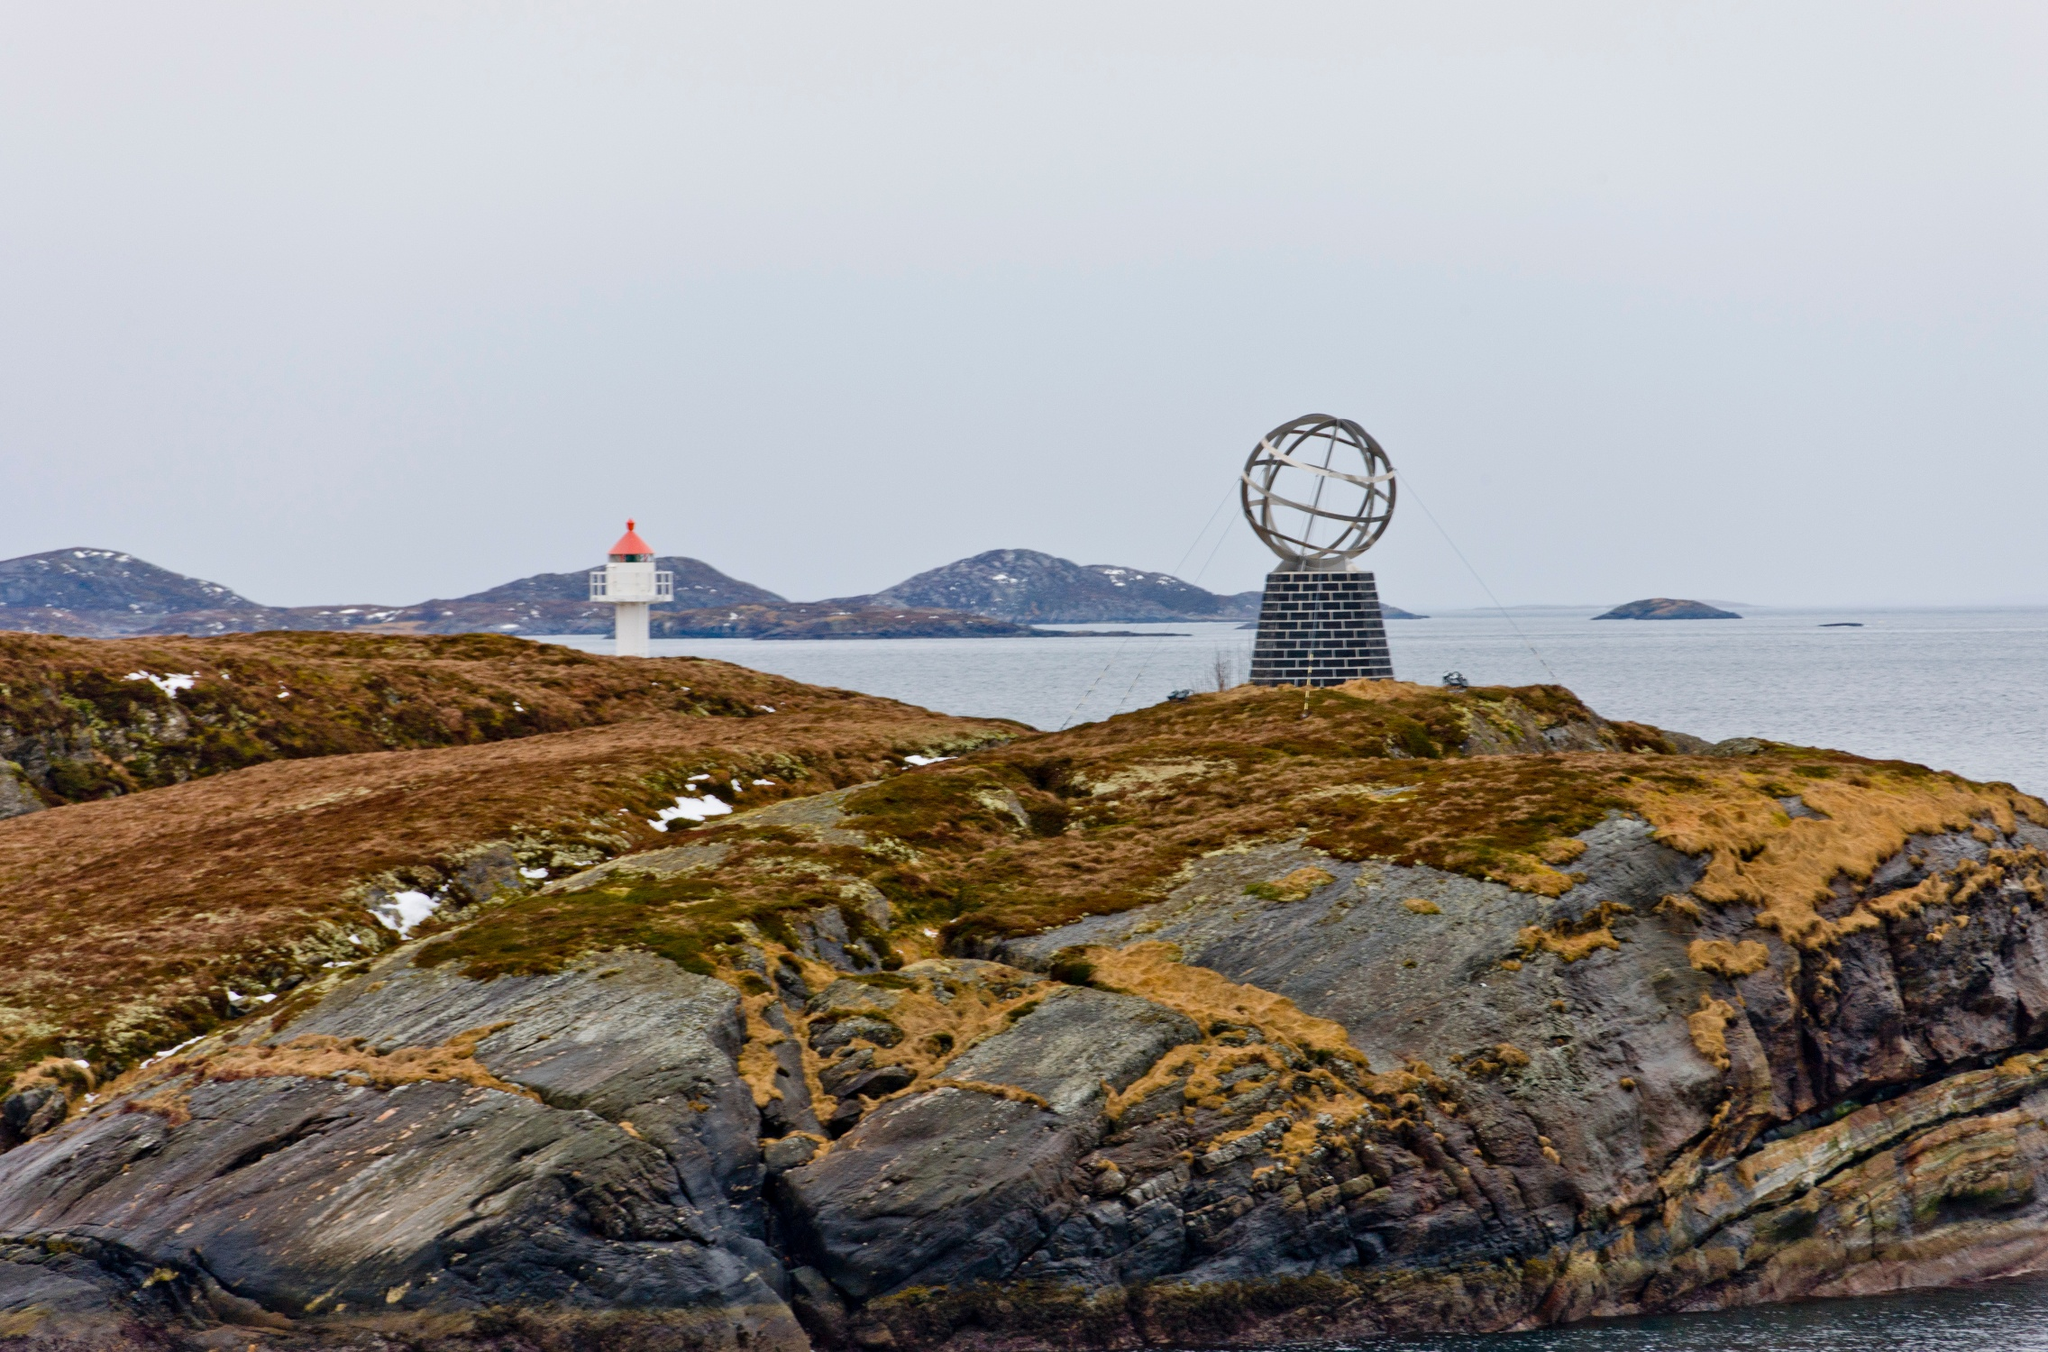What role does the lighthouse play in the context of this location? The lighthouse illustrated in the distance plays a crucial role in ensuring safe maritime navigation around the rocky shores of Magerøya island. Given the extreme northern location and the challenging sea conditions in this part of the world, the lighthouse serves as an essential beacon for ships, indicating safe passages and warning against potential hazards. Its strategic placement and distinctive white and red coloring ensure high visibility against the often murky and fog-laden Arctic atmosphere. 